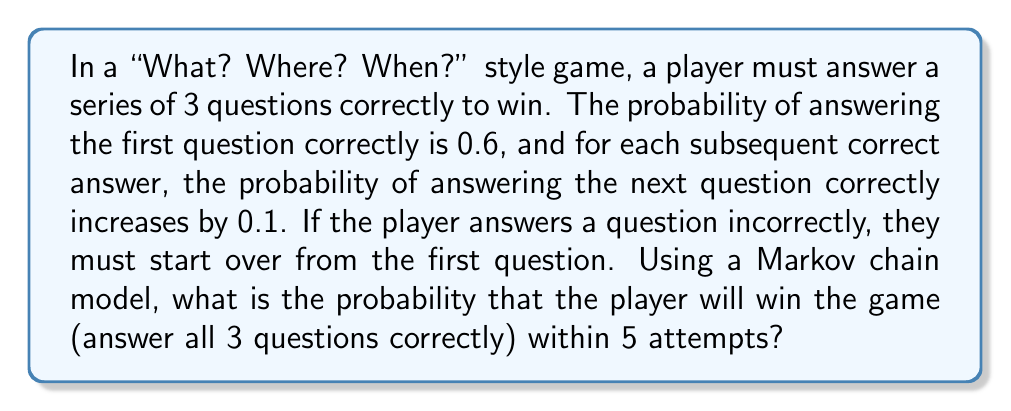Provide a solution to this math problem. Let's approach this step-by-step using a Markov chain model:

1) Define the states:
   State 0: Starting point
   State 1: Answered 1 question correctly
   State 2: Answered 2 questions correctly
   State 3: Won (answered all 3 questions correctly)

2) Create the transition probability matrix P:

   $$P = \begin{bmatrix}
   0.4 & 0.6 & 0 & 0 \\
   0.3 & 0 & 0.7 & 0 \\
   0.2 & 0 & 0 & 0.8 \\
   0 & 0 & 0 & 1
   \end{bmatrix}$$

3) To find the probability of winning within 5 attempts, we need to calculate $P^5$ and look at the entry in the first row, fourth column.

4) Using matrix multiplication (or a computer algebra system), we get:

   $$P^5 = \begin{bmatrix}
   0.0874 & 0.1311 & 0.1965 & 0.5850 \\
   0.0656 & 0.0983 & 0.1474 & 0.6887 \\
   0.0437 & 0.0656 & 0.0983 & 0.7924 \\
   0 & 0 & 0 & 1
   \end{bmatrix}$$

5) The probability of winning within 5 attempts, starting from state 0, is given by the entry in the first row, fourth column of $P^5$, which is approximately 0.5850.
Answer: 0.5850 